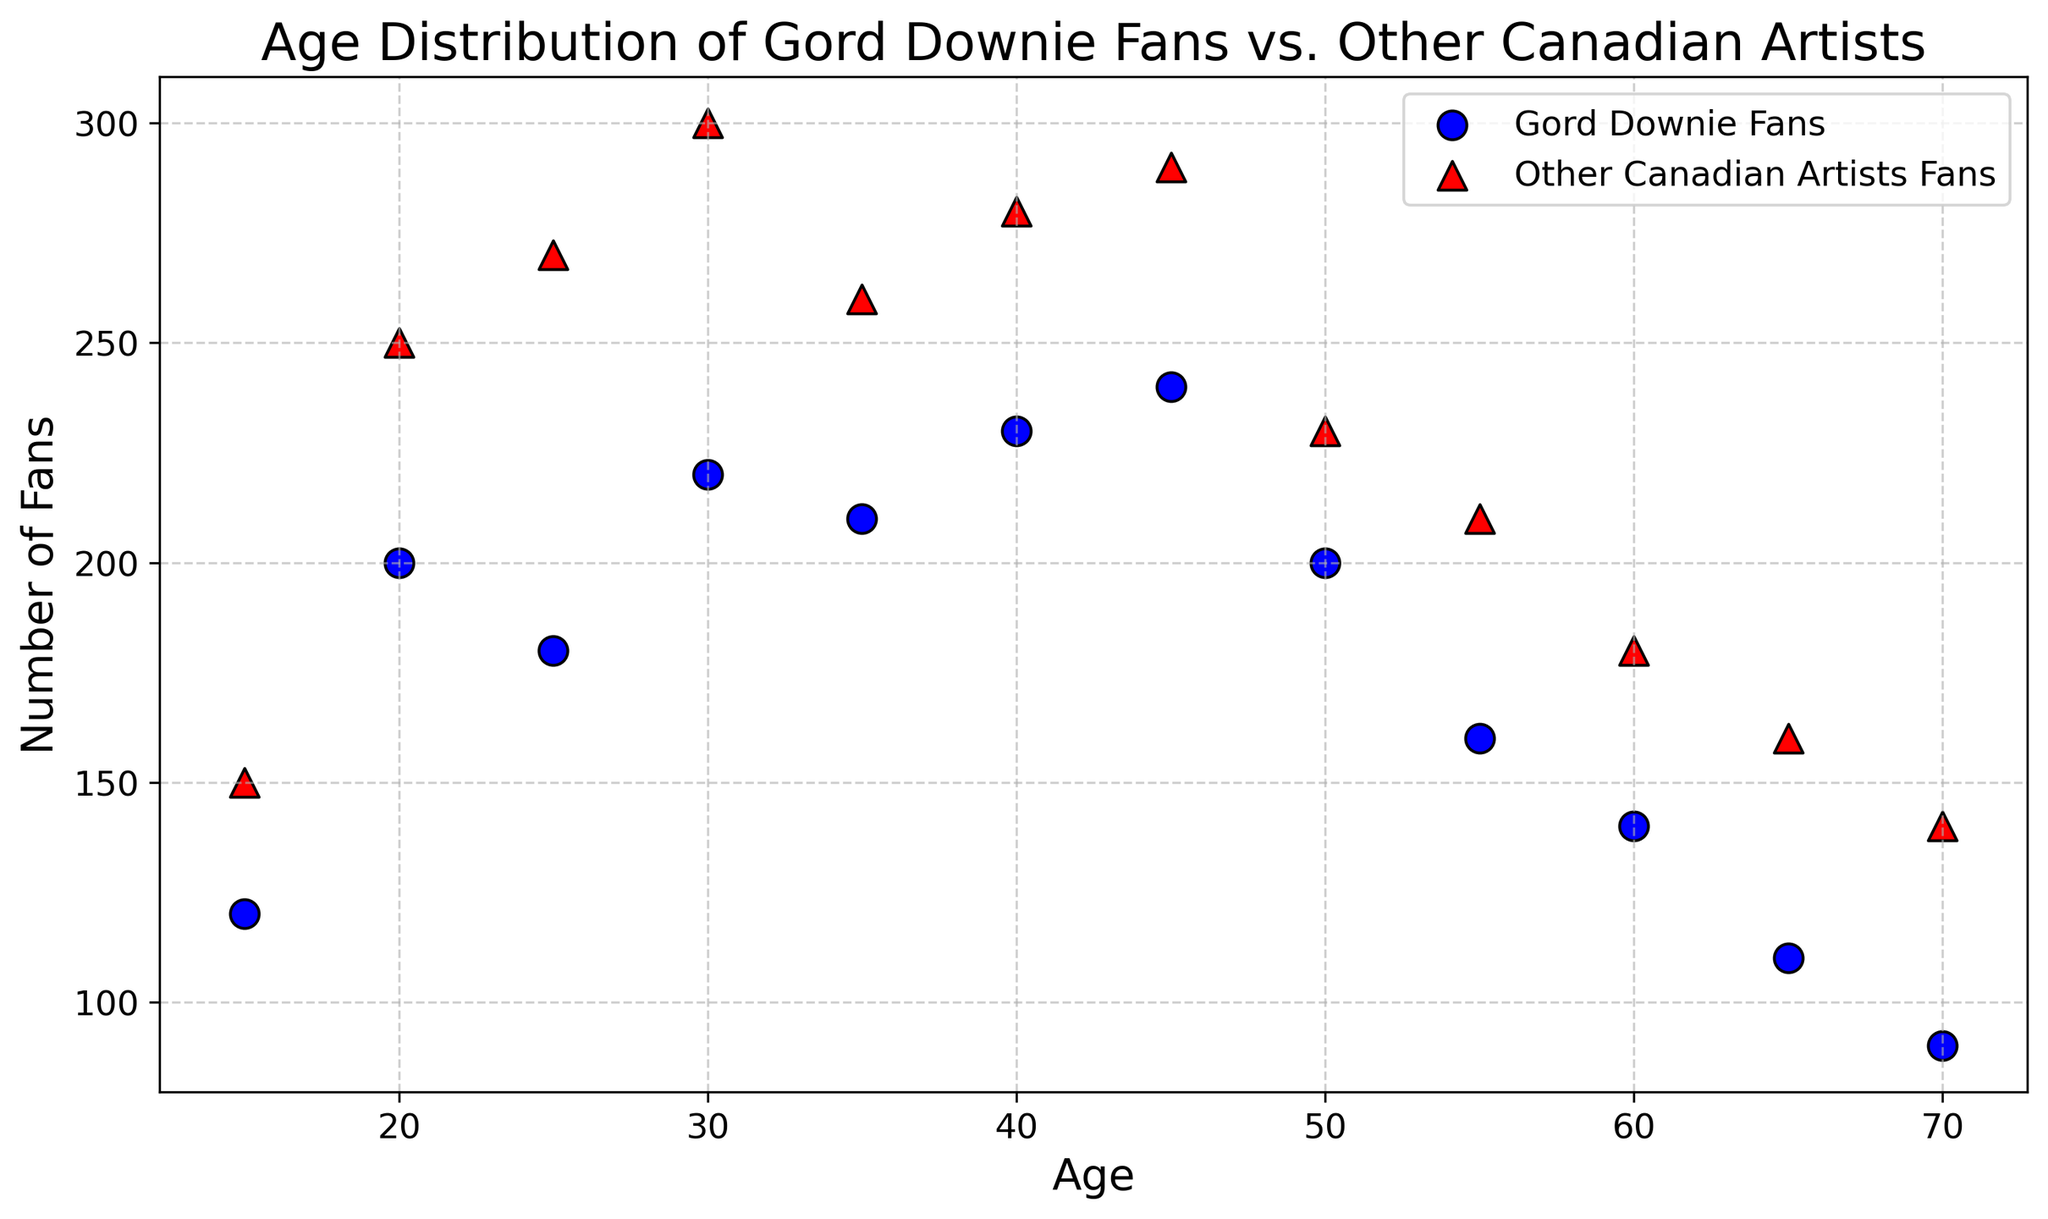What's the age group with the highest number of Gord Downie Fans? By visually inspecting the scatter plot, look for the age value corresponding to the highest data point (blue circle) for Gord Downie fans. The highest blue circle is located at age 45.
Answer: 45 At what age do Gord Downie Fans and Other Canadian Artists Fans have the smallest difference in their numbers? Observe the distances between the blue circles and red triangles. The closest points are at age 55 where the difference between the two groups is smallest (160 vs 210, which is a difference of 50).
Answer: 55 For which age group is the number of Other Canadian Artists Fans the highest? Identify the age value corresponding to the highest red triangle on the scatter plot. The highest red triangle is located at age 30.
Answer: 30 What is the average number of Gord Downie Fans for ages 30 to 40? Sum the values of Gord Downie Fans for ages 30, 35, and 40. These values are 220, 210, and 230 respectively. The average is (220 + 210 + 230) / 3 = 660 / 3 = 220.
Answer: 220 Is the number of Gord Downie Fans greater than the number of Other Canadian Artists Fans for any age group(s)? If so, which ones? Compare the values for Gord Downie Fans and Other Canadian Artists Fans at each age group. Gord Downie Fans exceed Other Canadian Artists Fans at ages 45 (240 vs 290) and 60 (140 vs 180). Therefore, the answer is no.
Answer: No What is the difference in the number of fans between Gord Downie Fans and Other Canadian Artists Fans at age 20? Check the scatter plot for the values at age 20. Gord Downie Fans are 200, and Other Canadian Artists Fans are 250. The difference is 250 - 200 = 50.
Answer: 50 Which age group shows the biggest drop in the number of Gord Downie Fans relative to the previous age group? Compare the differences between successive age groups for Gord Downie Fans. The biggest drop is between age 50 and 55 (200 - 160 = 40).
Answer: 50 to 55 Are there any age groups where the number of Gord Downie Fans and Other Canadian Artists Fans are equal? Look for points on the scatter plot where blue circles and red triangles overlap. None of the points overlap.
Answer: No What's the median number of Gord Downie Fans across all age groups? List the number of Gord Downie Fans in ascending order: [90, 110, 120, 140, 160, 180, 200, 200, 210, 220, 230, 240]. The median is the average of the 6th and 7th data points, (180 + 200) / 2 = 380 / 2 = 190.
Answer: 190 